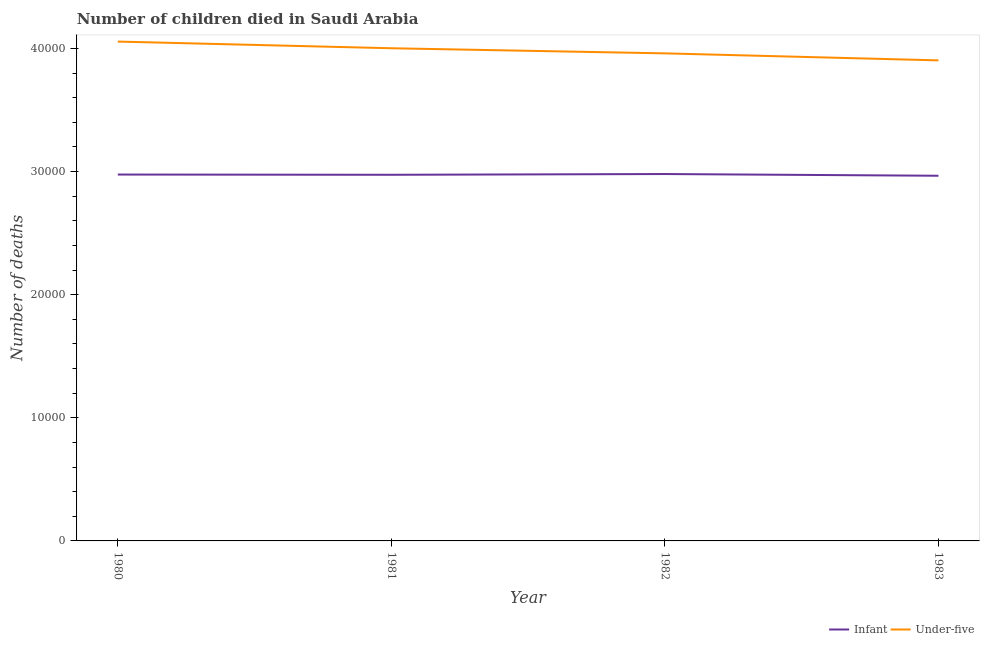Does the line corresponding to number of under-five deaths intersect with the line corresponding to number of infant deaths?
Ensure brevity in your answer.  No. What is the number of under-five deaths in 1982?
Make the answer very short. 3.96e+04. Across all years, what is the maximum number of infant deaths?
Your answer should be very brief. 2.98e+04. Across all years, what is the minimum number of infant deaths?
Your answer should be compact. 2.97e+04. In which year was the number of under-five deaths maximum?
Your response must be concise. 1980. What is the total number of under-five deaths in the graph?
Offer a very short reply. 1.59e+05. What is the difference between the number of under-five deaths in 1980 and that in 1981?
Give a very brief answer. 541. What is the difference between the number of under-five deaths in 1980 and the number of infant deaths in 1983?
Your answer should be compact. 1.09e+04. What is the average number of infant deaths per year?
Your answer should be compact. 2.97e+04. In the year 1983, what is the difference between the number of infant deaths and number of under-five deaths?
Your answer should be very brief. -9370. What is the ratio of the number of under-five deaths in 1980 to that in 1983?
Provide a succinct answer. 1.04. What is the difference between the highest and the second highest number of infant deaths?
Provide a succinct answer. 42. What is the difference between the highest and the lowest number of infant deaths?
Keep it short and to the point. 139. In how many years, is the number of under-five deaths greater than the average number of under-five deaths taken over all years?
Provide a short and direct response. 2. Is the sum of the number of under-five deaths in 1980 and 1983 greater than the maximum number of infant deaths across all years?
Your answer should be compact. Yes. Does the number of infant deaths monotonically increase over the years?
Ensure brevity in your answer.  No. Is the number of under-five deaths strictly greater than the number of infant deaths over the years?
Provide a short and direct response. Yes. Is the number of infant deaths strictly less than the number of under-five deaths over the years?
Provide a short and direct response. Yes. How many years are there in the graph?
Your answer should be very brief. 4. Are the values on the major ticks of Y-axis written in scientific E-notation?
Offer a terse response. No. Does the graph contain any zero values?
Ensure brevity in your answer.  No. Does the graph contain grids?
Your answer should be very brief. No. Where does the legend appear in the graph?
Offer a very short reply. Bottom right. How many legend labels are there?
Provide a succinct answer. 2. How are the legend labels stacked?
Offer a terse response. Horizontal. What is the title of the graph?
Your response must be concise. Number of children died in Saudi Arabia. Does "Female" appear as one of the legend labels in the graph?
Your answer should be compact. No. What is the label or title of the Y-axis?
Your answer should be very brief. Number of deaths. What is the Number of deaths of Infant in 1980?
Your answer should be very brief. 2.98e+04. What is the Number of deaths in Under-five in 1980?
Offer a very short reply. 4.06e+04. What is the Number of deaths in Infant in 1981?
Offer a very short reply. 2.97e+04. What is the Number of deaths in Under-five in 1981?
Ensure brevity in your answer.  4.00e+04. What is the Number of deaths in Infant in 1982?
Ensure brevity in your answer.  2.98e+04. What is the Number of deaths in Under-five in 1982?
Provide a short and direct response. 3.96e+04. What is the Number of deaths in Infant in 1983?
Give a very brief answer. 2.97e+04. What is the Number of deaths of Under-five in 1983?
Offer a very short reply. 3.90e+04. Across all years, what is the maximum Number of deaths of Infant?
Your answer should be compact. 2.98e+04. Across all years, what is the maximum Number of deaths of Under-five?
Provide a succinct answer. 4.06e+04. Across all years, what is the minimum Number of deaths of Infant?
Give a very brief answer. 2.97e+04. Across all years, what is the minimum Number of deaths in Under-five?
Provide a succinct answer. 3.90e+04. What is the total Number of deaths of Infant in the graph?
Offer a terse response. 1.19e+05. What is the total Number of deaths of Under-five in the graph?
Offer a very short reply. 1.59e+05. What is the difference between the Number of deaths of Infant in 1980 and that in 1981?
Provide a succinct answer. 19. What is the difference between the Number of deaths in Under-five in 1980 and that in 1981?
Give a very brief answer. 541. What is the difference between the Number of deaths in Infant in 1980 and that in 1982?
Your answer should be compact. -42. What is the difference between the Number of deaths of Under-five in 1980 and that in 1982?
Offer a very short reply. 957. What is the difference between the Number of deaths in Infant in 1980 and that in 1983?
Make the answer very short. 97. What is the difference between the Number of deaths in Under-five in 1980 and that in 1983?
Make the answer very short. 1526. What is the difference between the Number of deaths in Infant in 1981 and that in 1982?
Provide a succinct answer. -61. What is the difference between the Number of deaths in Under-five in 1981 and that in 1982?
Keep it short and to the point. 416. What is the difference between the Number of deaths in Infant in 1981 and that in 1983?
Your response must be concise. 78. What is the difference between the Number of deaths in Under-five in 1981 and that in 1983?
Your response must be concise. 985. What is the difference between the Number of deaths of Infant in 1982 and that in 1983?
Make the answer very short. 139. What is the difference between the Number of deaths of Under-five in 1982 and that in 1983?
Ensure brevity in your answer.  569. What is the difference between the Number of deaths in Infant in 1980 and the Number of deaths in Under-five in 1981?
Provide a short and direct response. -1.03e+04. What is the difference between the Number of deaths of Infant in 1980 and the Number of deaths of Under-five in 1982?
Your answer should be compact. -9842. What is the difference between the Number of deaths in Infant in 1980 and the Number of deaths in Under-five in 1983?
Provide a succinct answer. -9273. What is the difference between the Number of deaths of Infant in 1981 and the Number of deaths of Under-five in 1982?
Keep it short and to the point. -9861. What is the difference between the Number of deaths of Infant in 1981 and the Number of deaths of Under-five in 1983?
Offer a terse response. -9292. What is the difference between the Number of deaths of Infant in 1982 and the Number of deaths of Under-five in 1983?
Give a very brief answer. -9231. What is the average Number of deaths in Infant per year?
Make the answer very short. 2.97e+04. What is the average Number of deaths in Under-five per year?
Give a very brief answer. 3.98e+04. In the year 1980, what is the difference between the Number of deaths of Infant and Number of deaths of Under-five?
Make the answer very short. -1.08e+04. In the year 1981, what is the difference between the Number of deaths in Infant and Number of deaths in Under-five?
Make the answer very short. -1.03e+04. In the year 1982, what is the difference between the Number of deaths in Infant and Number of deaths in Under-five?
Provide a succinct answer. -9800. In the year 1983, what is the difference between the Number of deaths in Infant and Number of deaths in Under-five?
Provide a succinct answer. -9370. What is the ratio of the Number of deaths of Infant in 1980 to that in 1981?
Keep it short and to the point. 1. What is the ratio of the Number of deaths in Under-five in 1980 to that in 1981?
Make the answer very short. 1.01. What is the ratio of the Number of deaths of Under-five in 1980 to that in 1982?
Provide a short and direct response. 1.02. What is the ratio of the Number of deaths in Under-five in 1980 to that in 1983?
Offer a very short reply. 1.04. What is the ratio of the Number of deaths in Infant in 1981 to that in 1982?
Provide a short and direct response. 1. What is the ratio of the Number of deaths of Under-five in 1981 to that in 1982?
Ensure brevity in your answer.  1.01. What is the ratio of the Number of deaths in Under-five in 1981 to that in 1983?
Keep it short and to the point. 1.03. What is the ratio of the Number of deaths in Infant in 1982 to that in 1983?
Make the answer very short. 1. What is the ratio of the Number of deaths of Under-five in 1982 to that in 1983?
Provide a short and direct response. 1.01. What is the difference between the highest and the second highest Number of deaths of Under-five?
Offer a terse response. 541. What is the difference between the highest and the lowest Number of deaths of Infant?
Provide a short and direct response. 139. What is the difference between the highest and the lowest Number of deaths of Under-five?
Your answer should be very brief. 1526. 